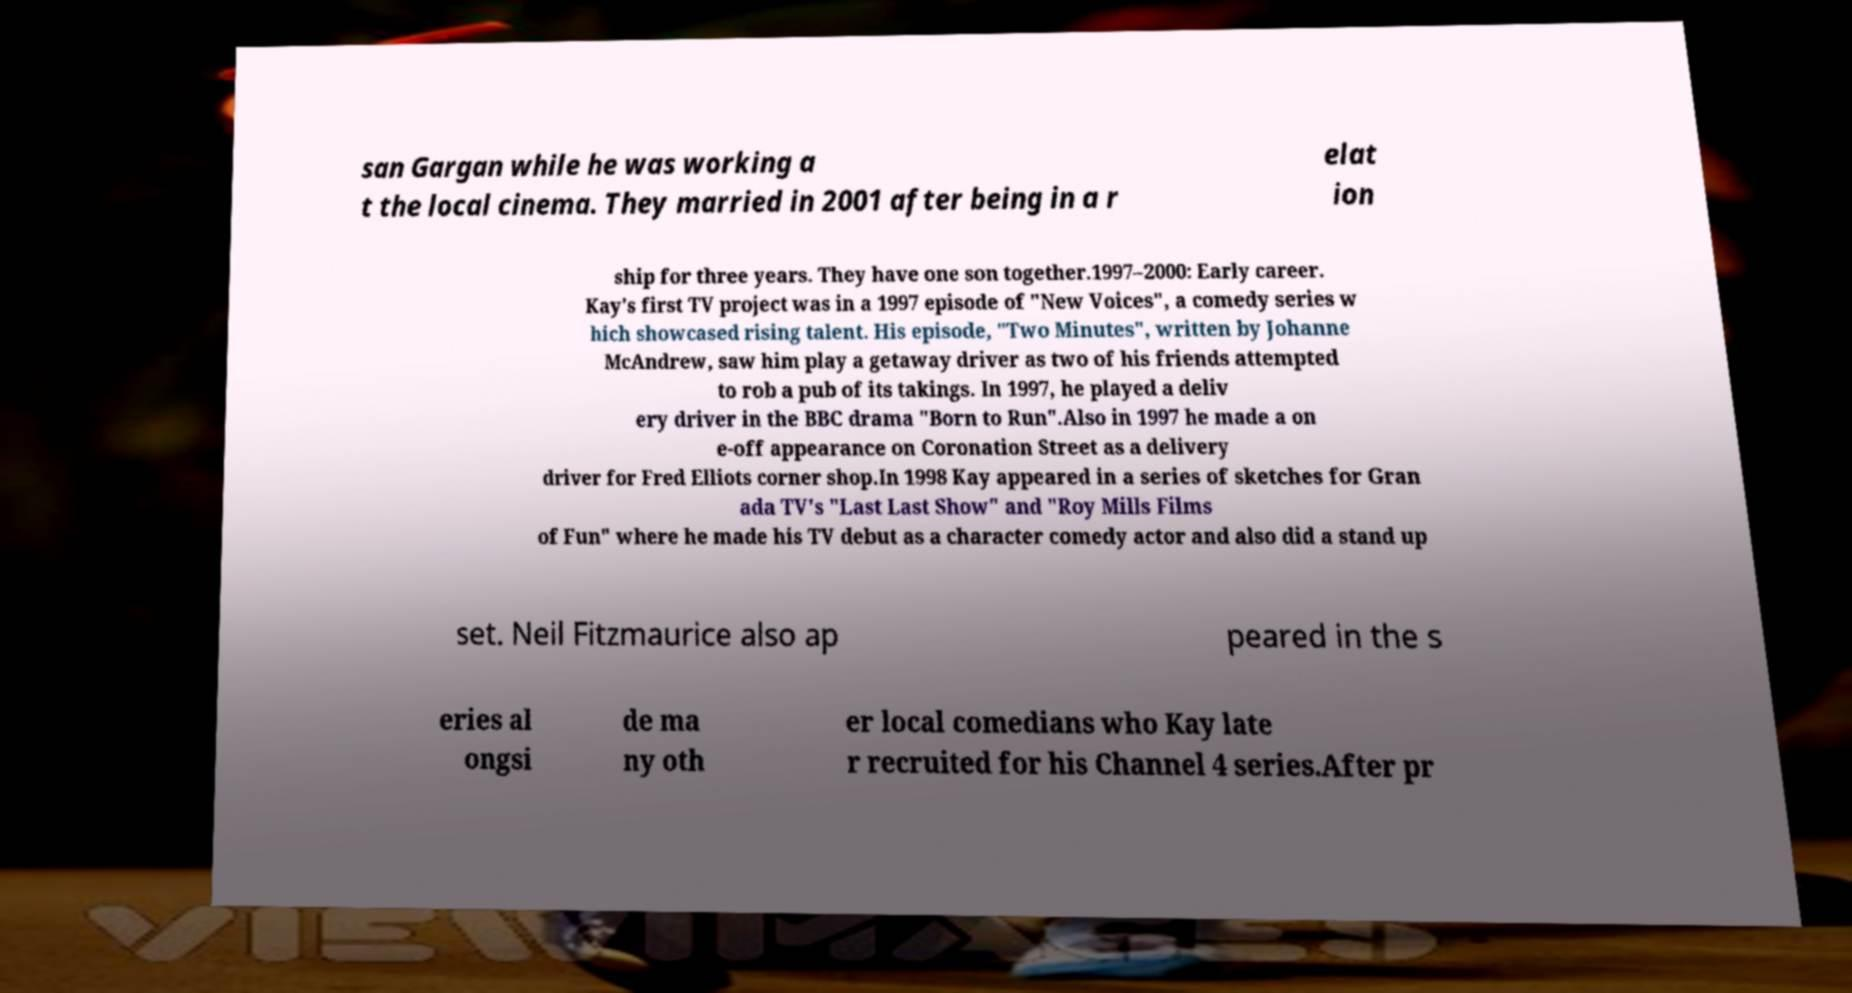Can you accurately transcribe the text from the provided image for me? san Gargan while he was working a t the local cinema. They married in 2001 after being in a r elat ion ship for three years. They have one son together.1997–2000: Early career. Kay's first TV project was in a 1997 episode of "New Voices", a comedy series w hich showcased rising talent. His episode, "Two Minutes", written by Johanne McAndrew, saw him play a getaway driver as two of his friends attempted to rob a pub of its takings. In 1997, he played a deliv ery driver in the BBC drama "Born to Run".Also in 1997 he made a on e-off appearance on Coronation Street as a delivery driver for Fred Elliots corner shop.In 1998 Kay appeared in a series of sketches for Gran ada TV's "Last Last Show" and "Roy Mills Films of Fun" where he made his TV debut as a character comedy actor and also did a stand up set. Neil Fitzmaurice also ap peared in the s eries al ongsi de ma ny oth er local comedians who Kay late r recruited for his Channel 4 series.After pr 